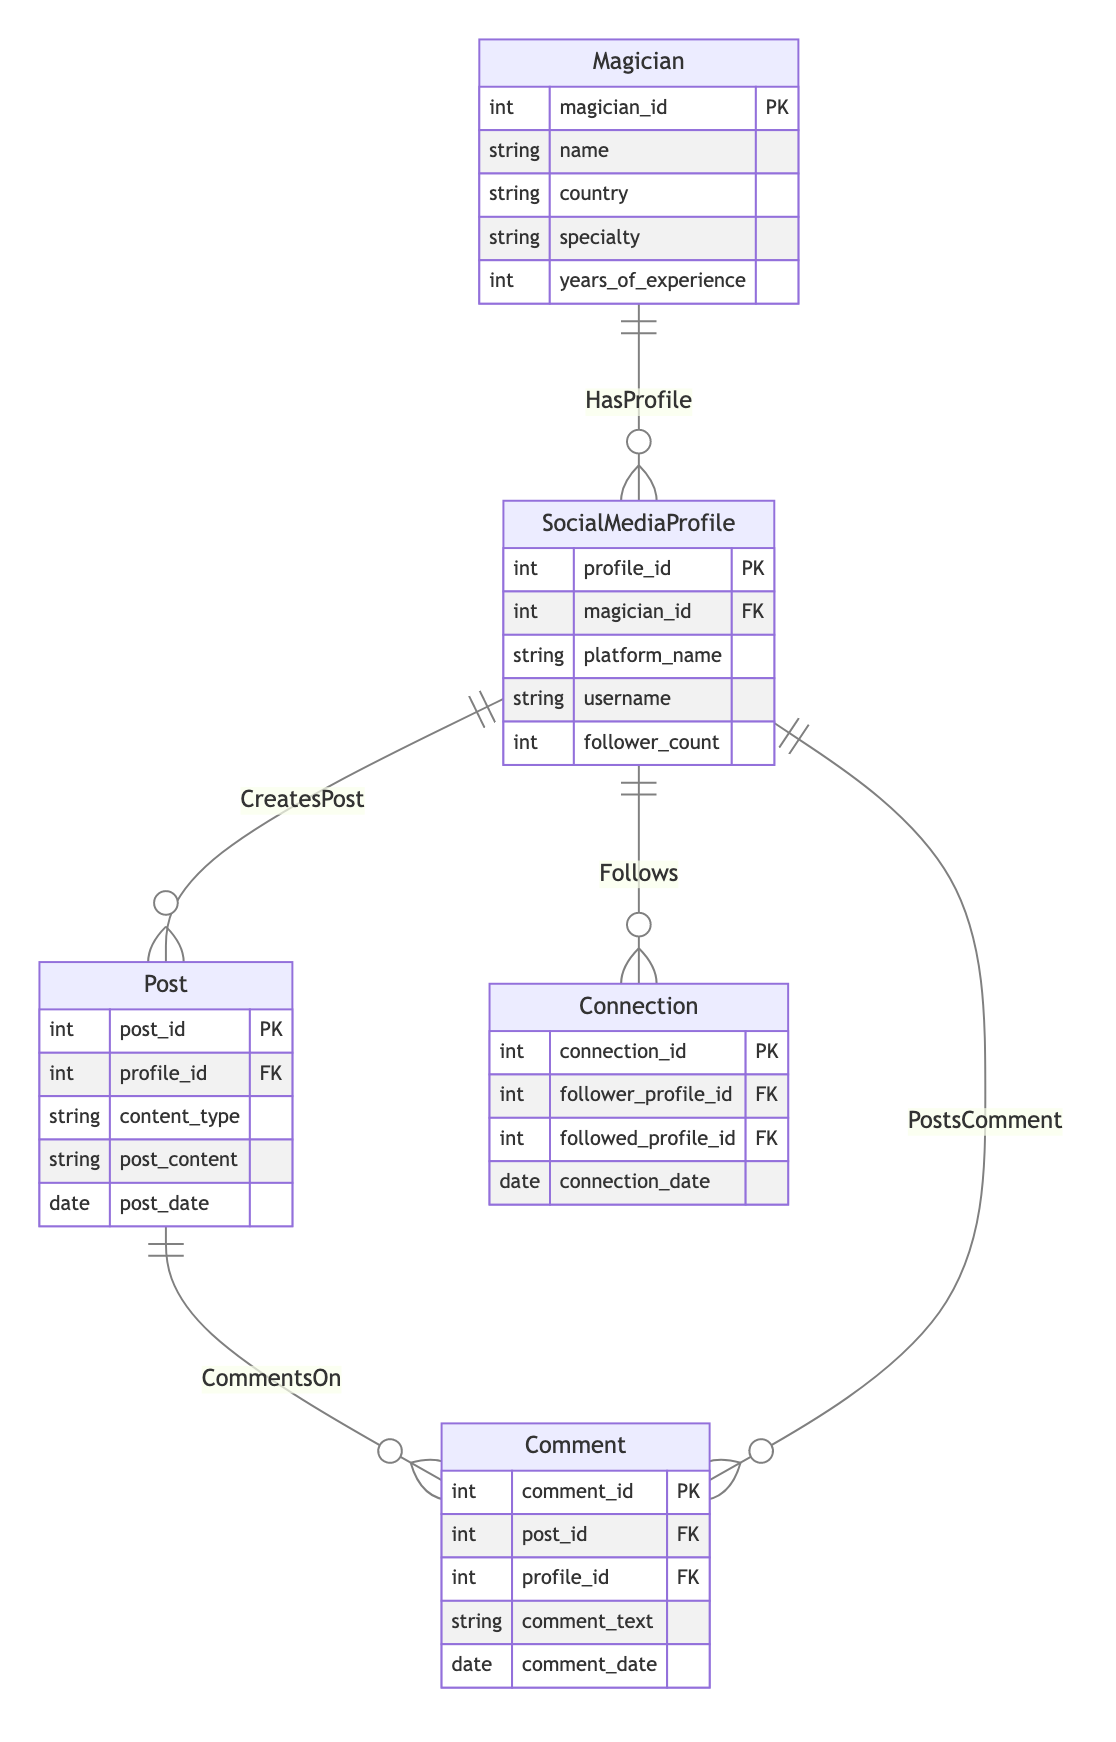What is the primary entity in the diagram? The primary entity is the one that most entities relate to directly without referencing others. In this diagram, "Magician" is the foundational entity, as both "SocialMediaProfile" and "Connection" derive from it.
Answer: Magician How many attributes does the "Post" entity have? To determine this, count the attributes listed under the "Post" entity in the diagram: post_id, profile_id, content_type, post_content, and post_date. Thus, there are five attributes.
Answer: 5 What is the relationship between "SocialMediaProfile" and "Post"? The relationship indicated in the diagram shows that a "SocialMediaProfile" can create multiple "Post" entries. This is denoted by the "CreatesPost" relationship, which indicates a one-to-many relationship.
Answer: CreatesPost How many relationships are described in the diagram? By inspecting the Relationships section in the diagram, there are a total of five distinct relationships, covering various actions between entities.
Answer: 5 What is the cardinality of the relationship between "Magician" and "SocialMediaProfile"? The cardinality notation shows that the "Magician" can have one to many "SocialMediaProfile" instances, indicating that a single magician can manage multiple social media profiles.
Answer: 1:N Which entity is related to the "Comment" entity through two different relationships? The "SocialMediaProfile" entity relates to "Comment" through two distinct relationships: "PostsComment" and "Follows." This dual connection indicates that a social media profile can comment on posts and also follow other profiles.
Answer: SocialMediaProfile What role does "Connection" play in the diagram? "Connection" serves as a bridge entity, defining the relationship where one user follows another in their social networks, represented by the "Follows" relationship, indicating interactions between members.
Answer: Follows How many different platforms can a "SocialMediaProfile" belong to based on this diagram? Given that no specific limit is stated in the entities or relationships, it suggests that a "SocialMediaProfile" can belong to various platforms, as it only refers to platform_name without further restrictions.
Answer: Multiple What is the purpose of the "Comment" entity in the diagram? The "Comment" entity is designed to capture feedback or discussions related to specific posts, indicating that multiple comments can be made on a single post, creating a one-to-many association.
Answer: Feedback on Posts 